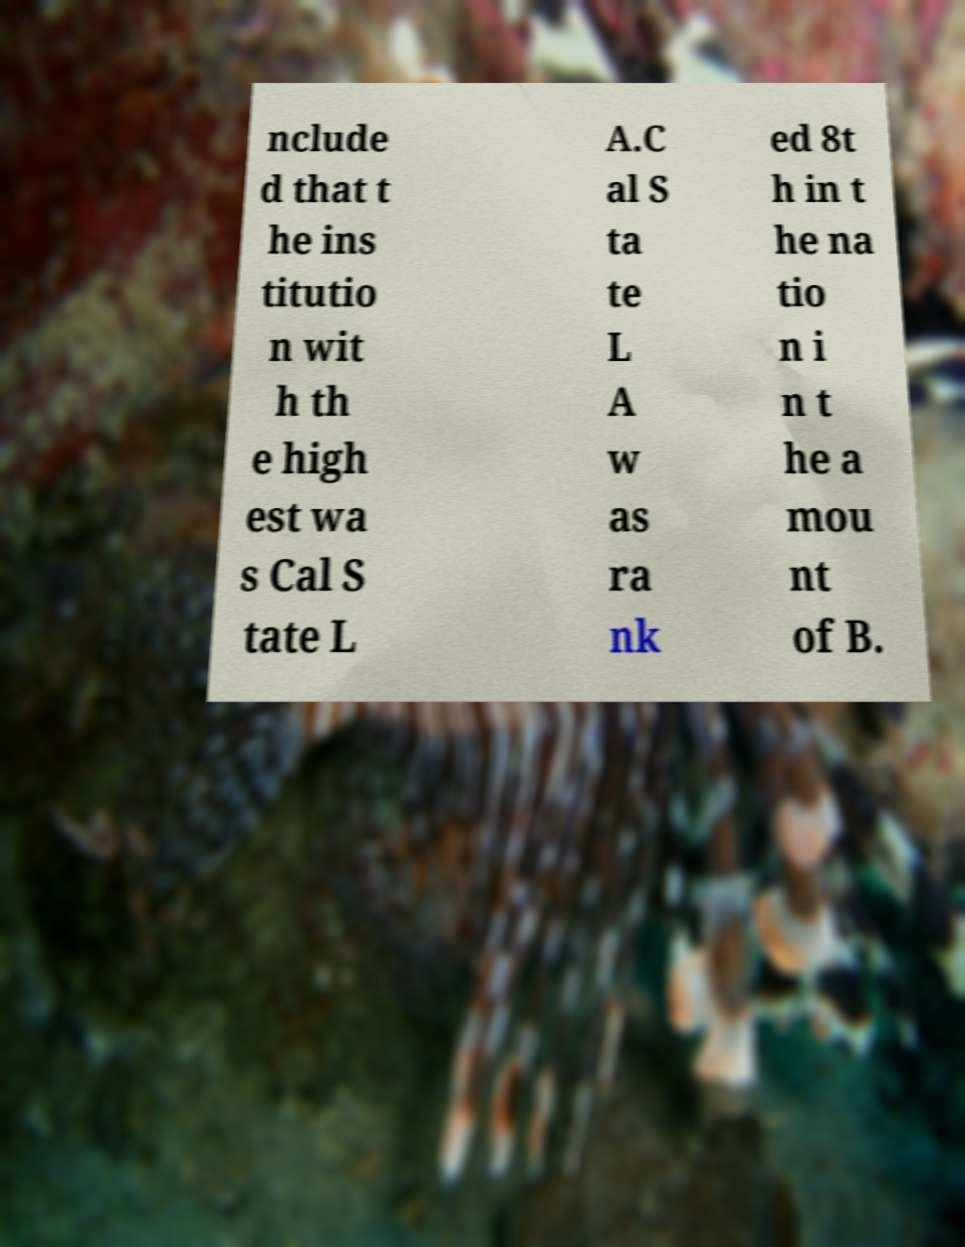For documentation purposes, I need the text within this image transcribed. Could you provide that? nclude d that t he ins titutio n wit h th e high est wa s Cal S tate L A.C al S ta te L A w as ra nk ed 8t h in t he na tio n i n t he a mou nt of B. 